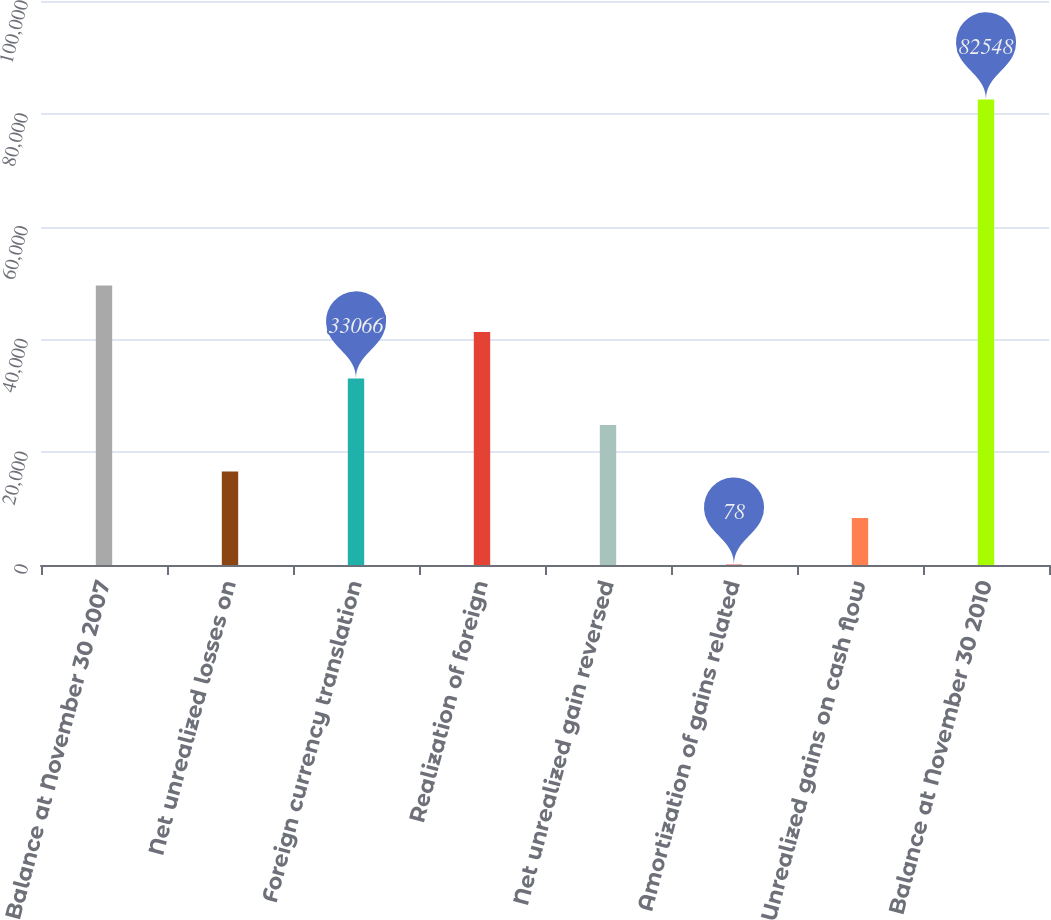Convert chart to OTSL. <chart><loc_0><loc_0><loc_500><loc_500><bar_chart><fcel>Balance at November 30 2007<fcel>Net unrealized losses on<fcel>Foreign currency translation<fcel>Realization of foreign<fcel>Net unrealized gain reversed<fcel>Amortization of gains related<fcel>Unrealized gains on cash flow<fcel>Balance at November 30 2010<nl><fcel>49560<fcel>16572<fcel>33066<fcel>41313<fcel>24819<fcel>78<fcel>8325<fcel>82548<nl></chart> 